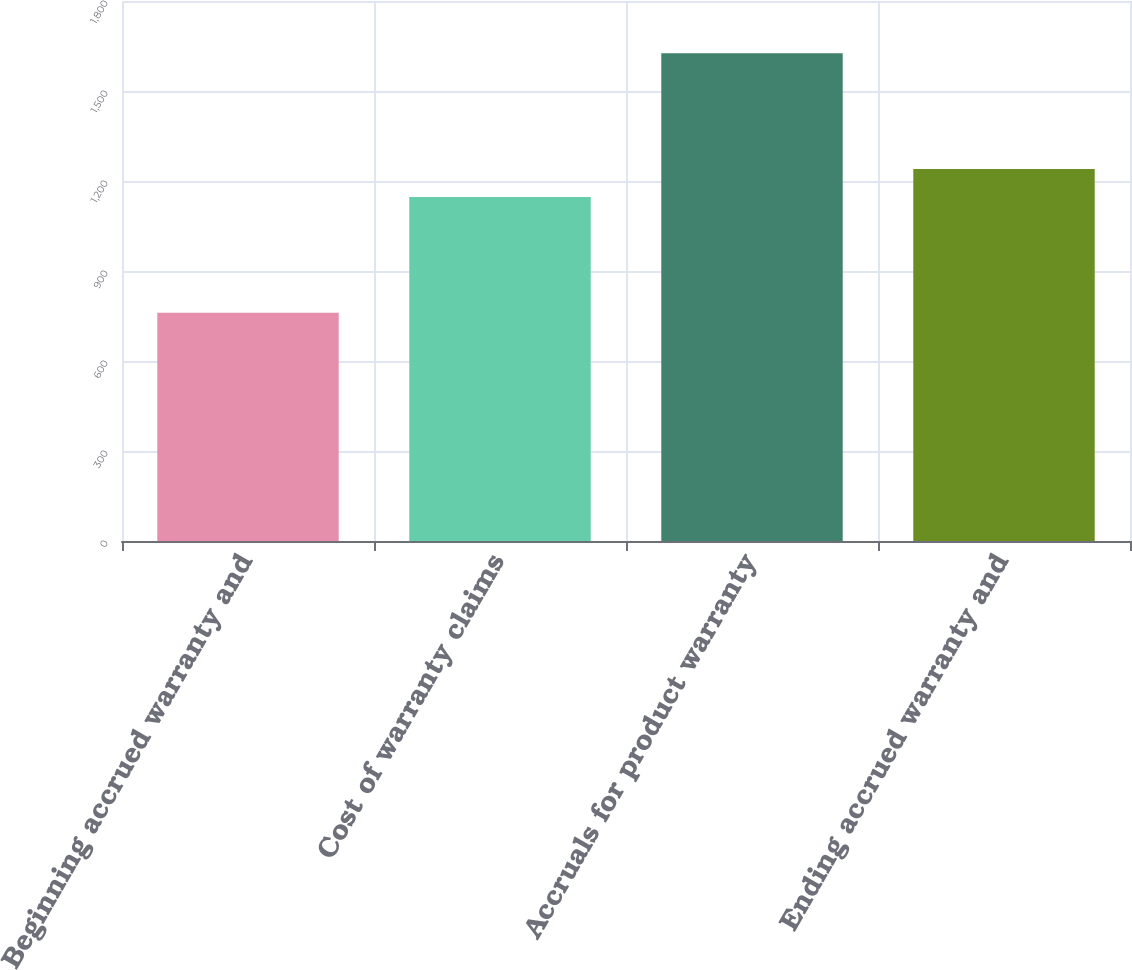Convert chart. <chart><loc_0><loc_0><loc_500><loc_500><bar_chart><fcel>Beginning accrued warranty and<fcel>Cost of warranty claims<fcel>Accruals for product warranty<fcel>Ending accrued warranty and<nl><fcel>761<fcel>1147<fcel>1626<fcel>1240<nl></chart> 